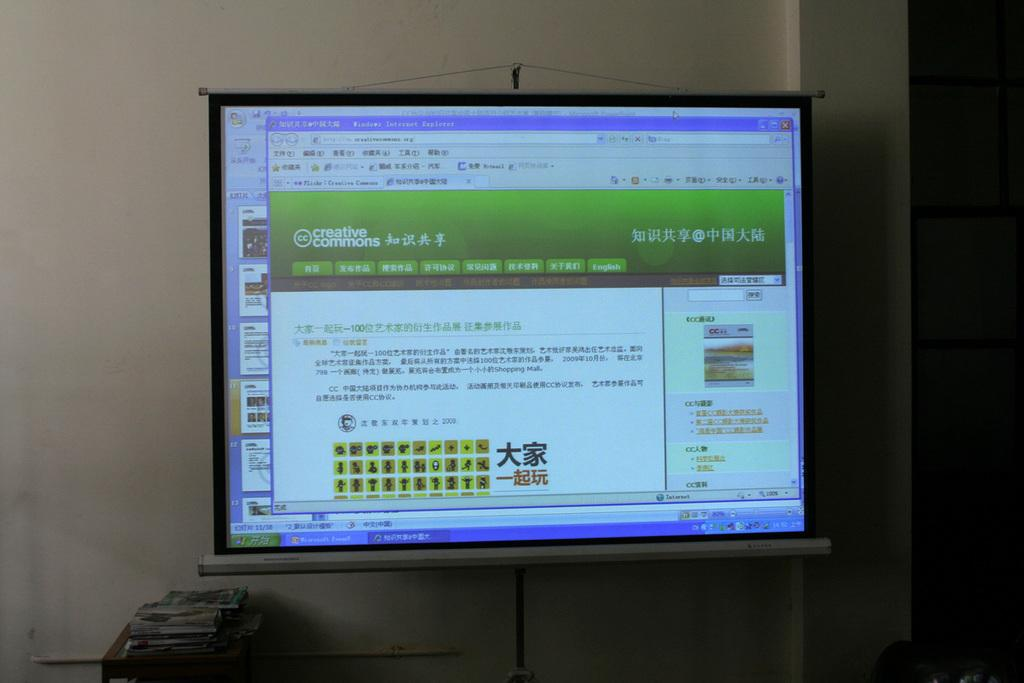<image>
Describe the image concisely. a computer monitor showing website Creative Commons and an asian language 